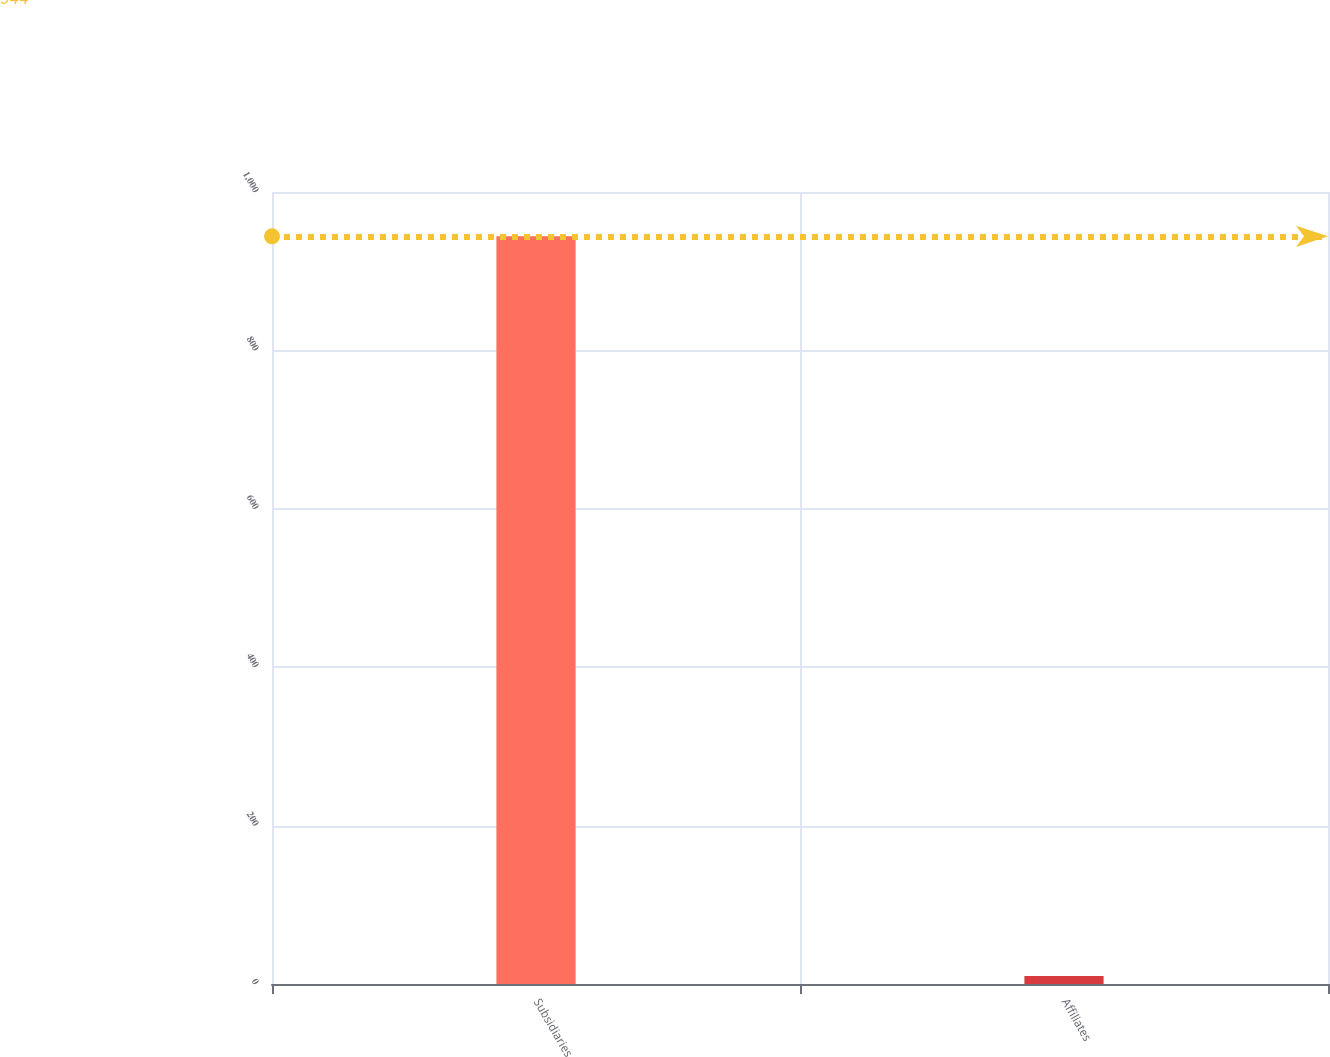<chart> <loc_0><loc_0><loc_500><loc_500><bar_chart><fcel>Subsidiaries<fcel>Affiliates<nl><fcel>944<fcel>10<nl></chart> 